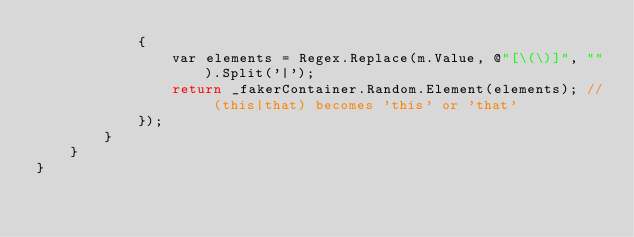<code> <loc_0><loc_0><loc_500><loc_500><_C#_>            {
                var elements = Regex.Replace(m.Value, @"[\(\)]", "").Split('|');
                return _fakerContainer.Random.Element(elements); // (this|that) becomes 'this' or 'that'
            });
        }
    }
}
</code> 